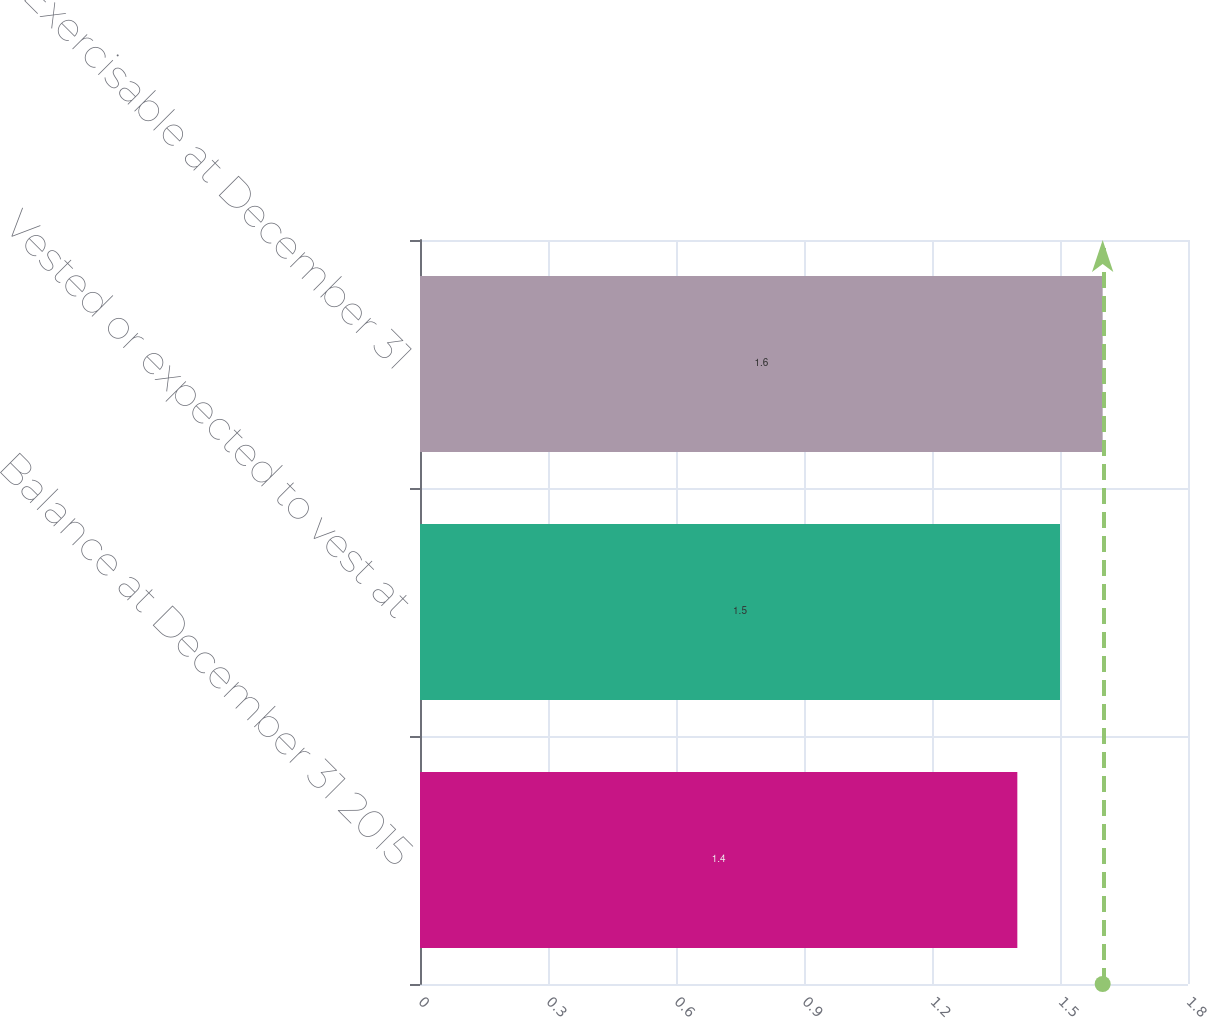Convert chart. <chart><loc_0><loc_0><loc_500><loc_500><bar_chart><fcel>Balance at December 31 2015<fcel>Vested or expected to vest at<fcel>Exercisable at December 31<nl><fcel>1.4<fcel>1.5<fcel>1.6<nl></chart> 